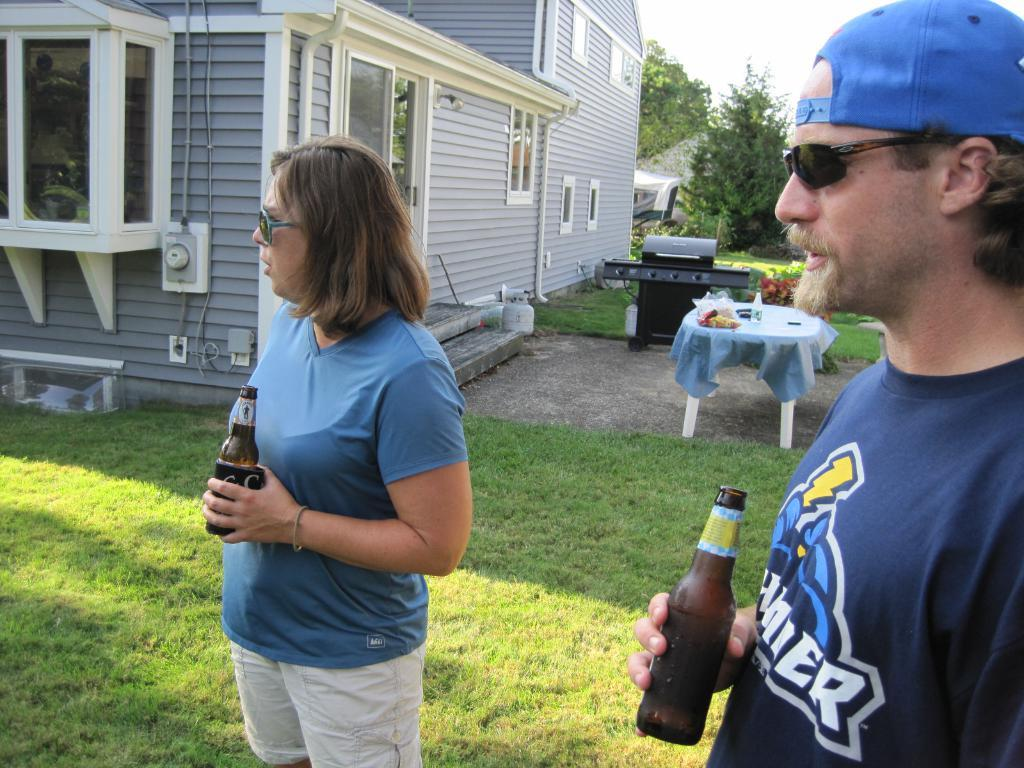Who are the people in the image? There is a woman and a man in the image. What are the woman and man doing in the image? The woman and man are standing and holding a bottle. What can be seen in the background of the image? There is a table, bottles, food, a building, a tree, and the sky visible in the background of the image. What type of jewel is the woman wearing in the image? There is no mention of any jewelry in the image, so it is not possible to determine if the woman is wearing a jewel. 